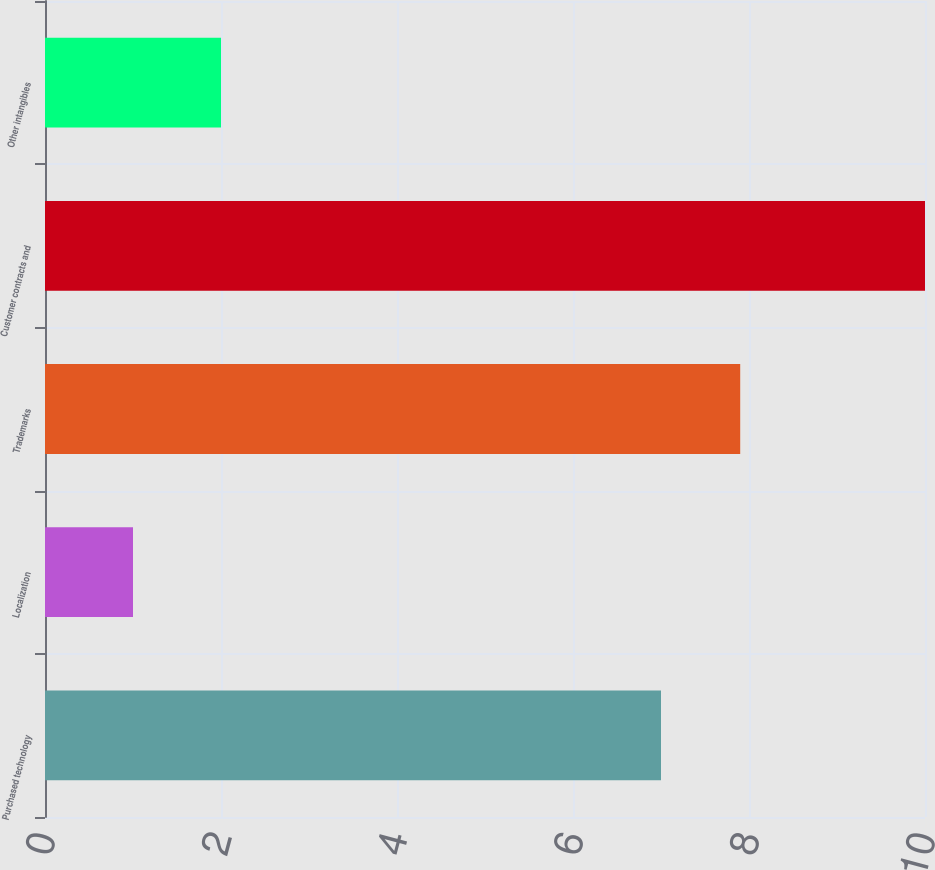<chart> <loc_0><loc_0><loc_500><loc_500><bar_chart><fcel>Purchased technology<fcel>Localization<fcel>Trademarks<fcel>Customer contracts and<fcel>Other intangibles<nl><fcel>7<fcel>1<fcel>7.9<fcel>10<fcel>2<nl></chart> 